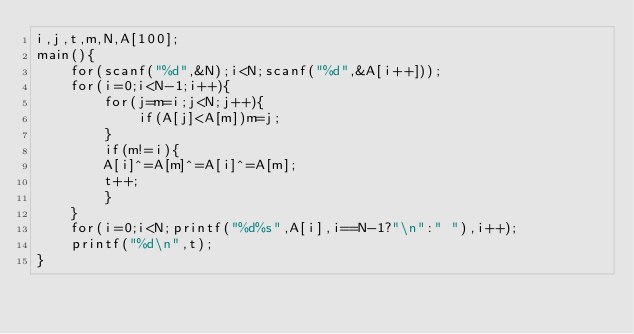<code> <loc_0><loc_0><loc_500><loc_500><_C_>i,j,t,m,N,A[100];
main(){
    for(scanf("%d",&N);i<N;scanf("%d",&A[i++]));
    for(i=0;i<N-1;i++){
        for(j=m=i;j<N;j++){
            if(A[j]<A[m])m=j;
        }
        if(m!=i){
        A[i]^=A[m]^=A[i]^=A[m];
        t++;
        }
    }
    for(i=0;i<N;printf("%d%s",A[i],i==N-1?"\n":" "),i++);
    printf("%d\n",t);
}</code> 